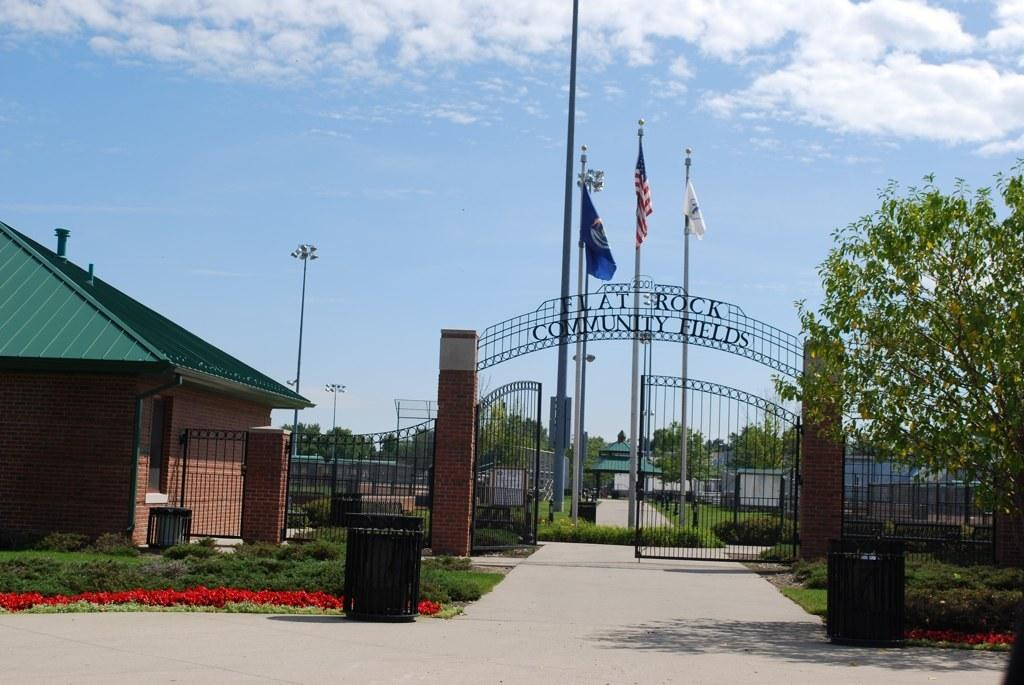What can be seen flying in the image? There are flags in the image. What type of structures are present in the image? There are buildings in the image. What type of vegetation is visible in the image? There are trees in the image. What type of entrance can be seen in the image? There are gates in the image. What type of barrier is present in the image? There is a fence in the image. What type of lighting is present in the background of the image? In the background, there are pole lights. What type of ground cover is visible in the background of the image? The grass is visible in the background. What type of pathway is visible in the background of the image? There is a road in the background. What type of sky is visible in the background of the image? The sky is visible in the background. What other objects can be seen on the ground in the background of the image? There are other objects on the ground in the background. How many cups of coffee does the secretary have on her desk in the image? There is no secretary or cups of coffee present in the image. What type of animal is sitting on the fence in the image? There are no animals present in the image. 